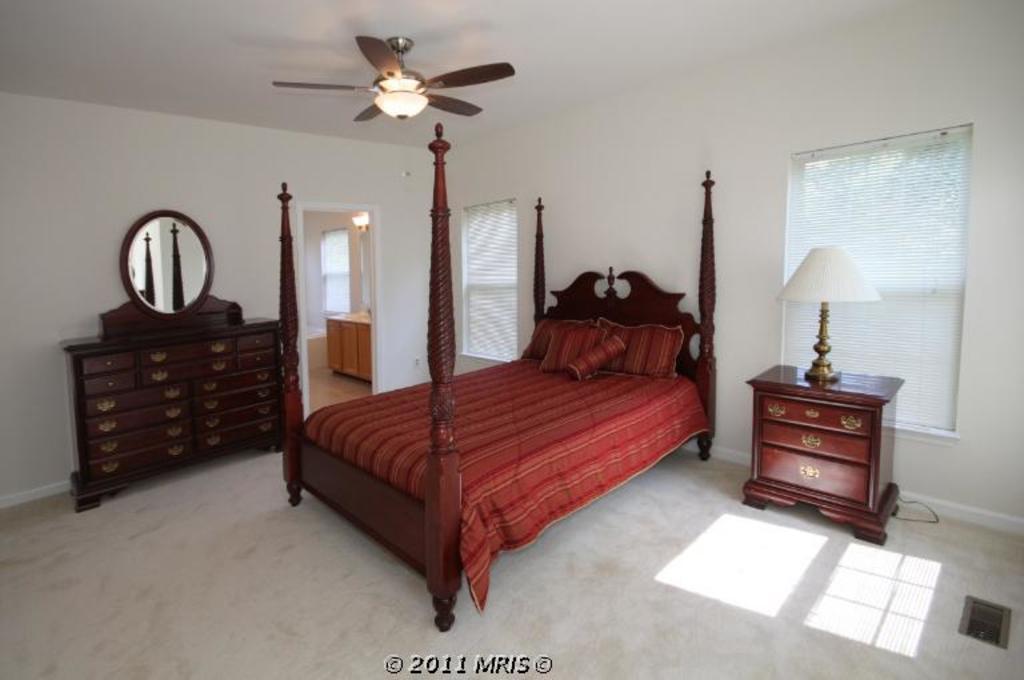Could you give a brief overview of what you see in this image? Fan is attached to the rooftop. These are windows. A bed with pillows. On this table there is a lamp. A mirror with cupboard. Bottom of the image there is a watermark. Inside this room there is a wooden cupboard. 